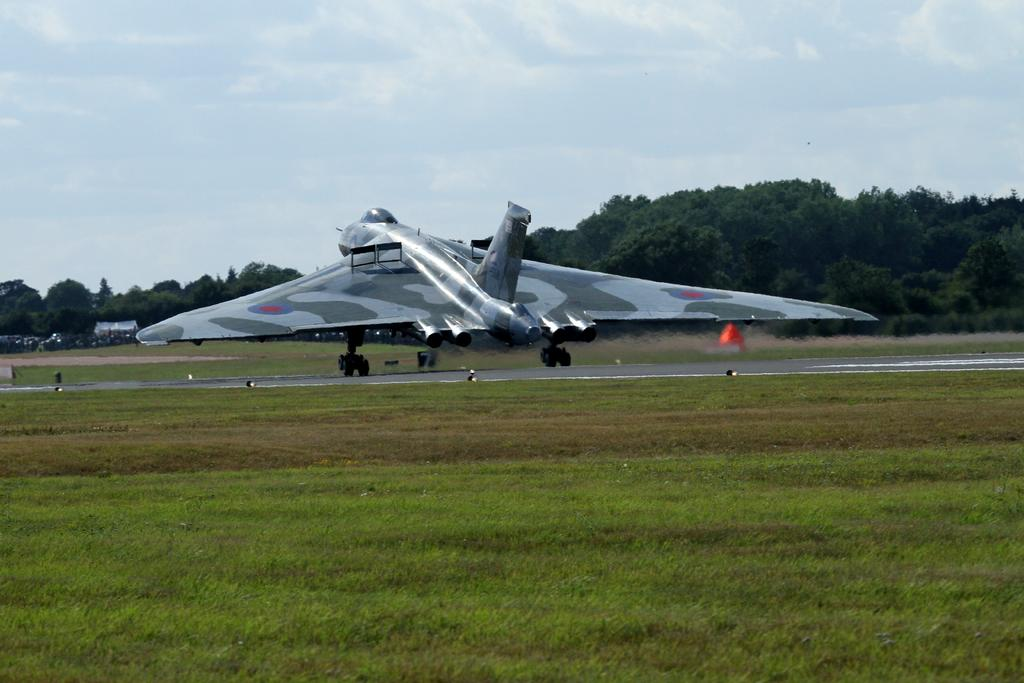What is happening in the image? There is a plan takeover in the image. What type of environment is depicted in the image? The side of the image is full of grass, and trees are present. What game is being played in the image? There is no game being played in the image; it depicts a plan takeover. What is the reason for the plan takeover in the image? The image does not provide information about the reason for the plan takeover. 